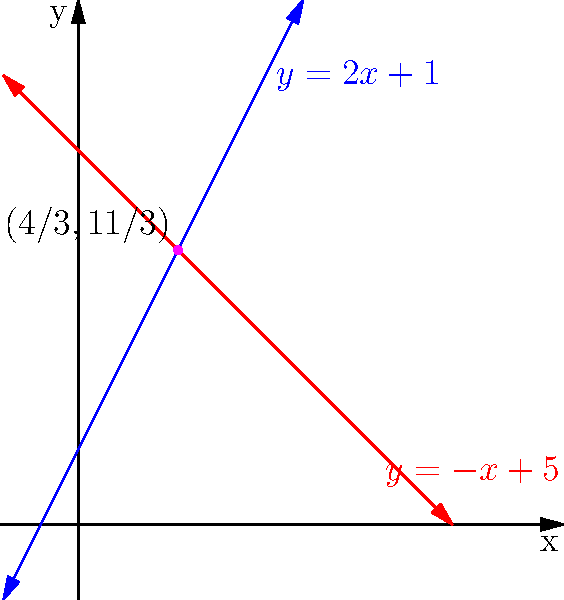In an urban planning project, two streets are modeled by the equations $y = 2x + 1$ and $y = -x + 5$. As an urban studies expert, how would you determine the exact coordinates of their intersection point? How might this information be used in urban development, and what limitations might exist in relying solely on these mathematical models without considering oral histories of the area? To find the intersection point of the two streets, we need to solve the system of linear equations:

$$\begin{cases}
y = 2x + 1 \\
y = -x + 5
\end{cases}$$

Step 1: Set the equations equal to each other since they intersect at a point where y-values are the same.
$2x + 1 = -x + 5$

Step 2: Solve for x
$3x = 4$
$x = \frac{4}{3}$

Step 3: Substitute this x-value into either equation to find y
$y = 2(\frac{4}{3}) + 1 = \frac{8}{3} + 1 = \frac{11}{3}$

Therefore, the intersection point is $(\frac{4}{3}, \frac{11}{3})$.

In urban development, this information could be used to:
1. Determine traffic flow and potential congestion points
2. Plan for infrastructure like traffic lights or roundabouts
3. Assess safety concerns at the intersection

Limitations of relying solely on mathematical models without oral histories:
1. Lack of historical context (e.g., cultural significance of the intersection)
2. Absence of community perspectives on usage patterns
3. Overlooking informal pathways or desire lines not captured by official plans
4. Missing information on local landmarks or gathering spots near the intersection

Incorporating oral histories alongside mathematical models would provide a more comprehensive understanding of the urban landscape, potentially leading to more inclusive and effective urban planning decisions.
Answer: Intersection point: $(\frac{4}{3}, \frac{11}{3})$ 